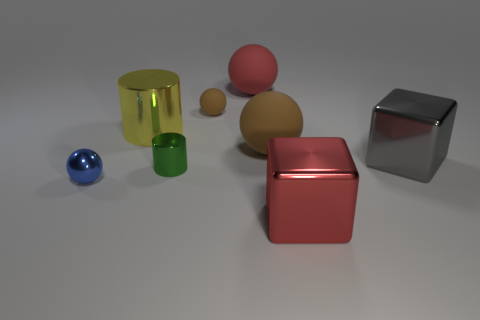Subtract all blue spheres. How many spheres are left? 3 Subtract 1 blocks. How many blocks are left? 1 Subtract all cubes. How many objects are left? 6 Subtract all purple blocks. How many brown balls are left? 2 Add 1 small blue metal spheres. How many objects exist? 9 Subtract all cyan balls. Subtract all purple cylinders. How many balls are left? 4 Subtract all green objects. Subtract all yellow objects. How many objects are left? 6 Add 2 metal cylinders. How many metal cylinders are left? 4 Add 2 metal cylinders. How many metal cylinders exist? 4 Subtract all red spheres. How many spheres are left? 3 